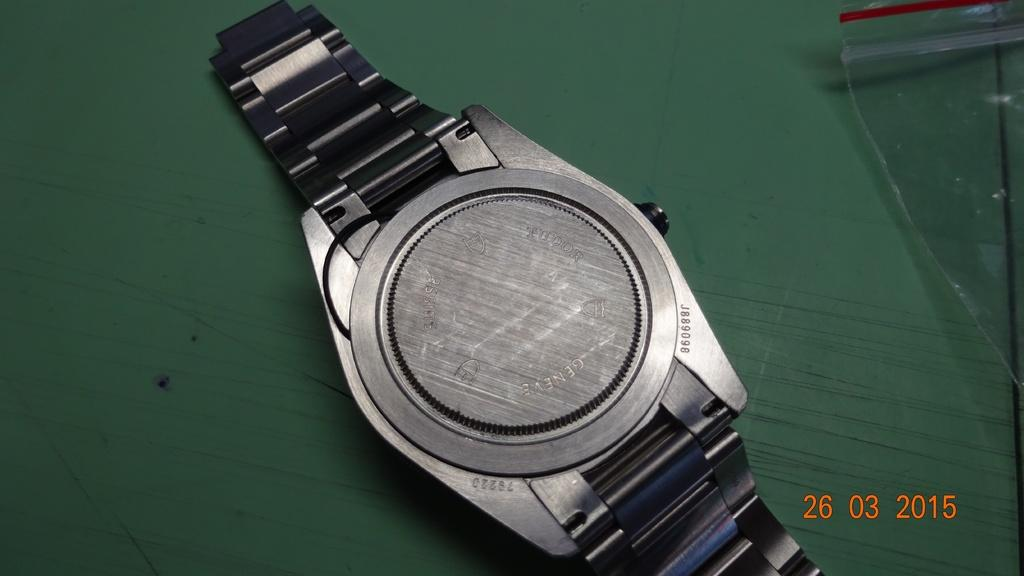<image>
Provide a brief description of the given image. The rear side of a watch is imprinted with the word Geneve. 